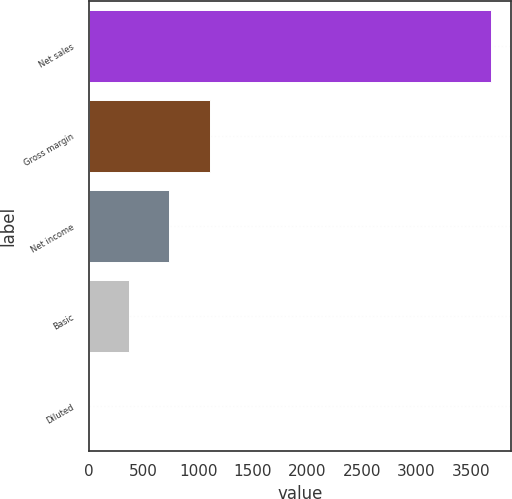Convert chart. <chart><loc_0><loc_0><loc_500><loc_500><bar_chart><fcel>Net sales<fcel>Gross margin<fcel>Net income<fcel>Basic<fcel>Diluted<nl><fcel>3678<fcel>1103.75<fcel>736<fcel>368.25<fcel>0.5<nl></chart> 